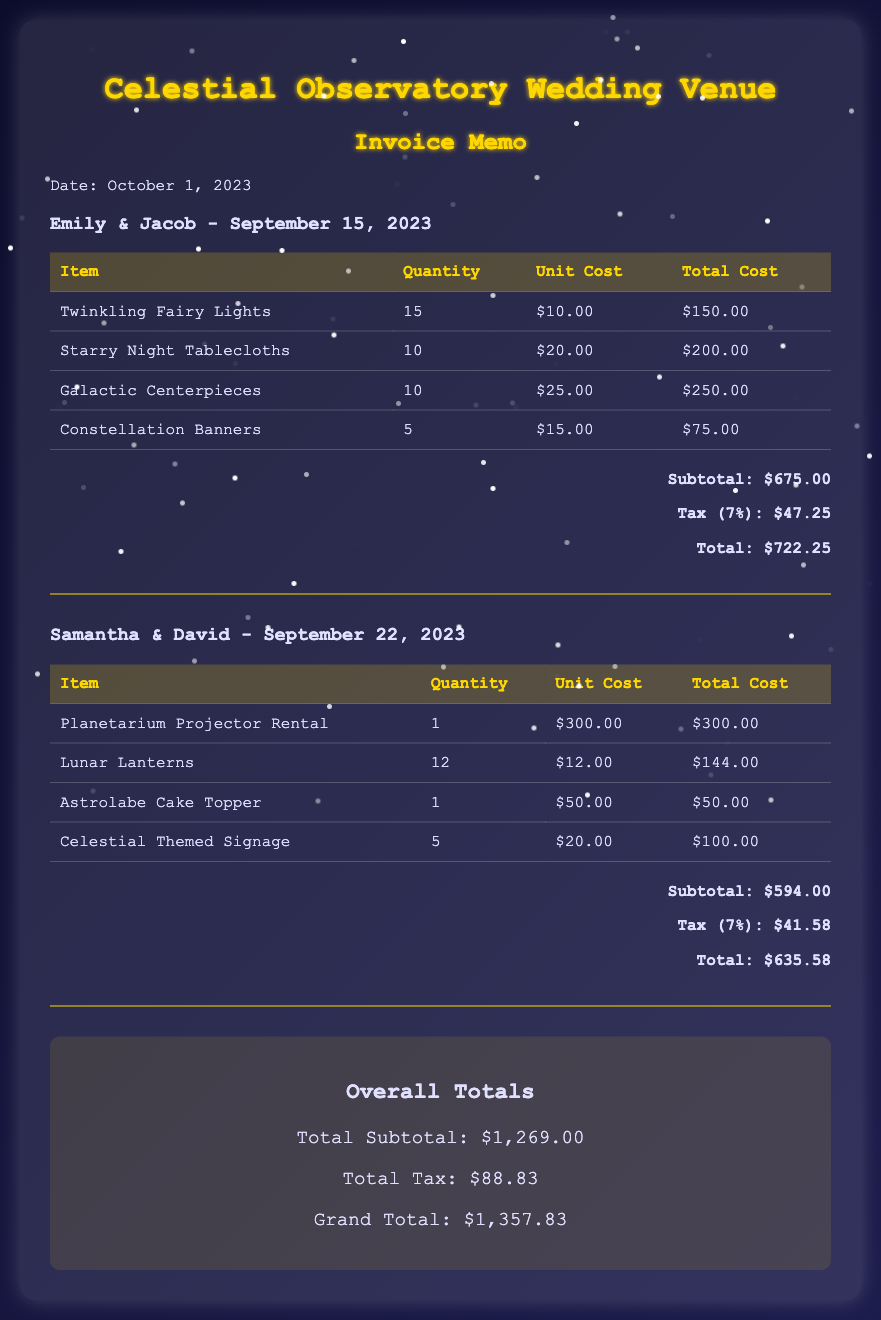What is the name of the first couple? The first couple mentioned in the document is Emily & Jacob.
Answer: Emily & Jacob What is the total cost of decorations for Samantha & David's wedding? The total cost for Samantha & David's wedding decorations is provided directly in the document.
Answer: $635.58 How many Galactic Centerpieces were purchased? The document lists the quantity of Galactic Centerpieces purchased.
Answer: 10 What is the tax percentage applied to the invoices? The tax percentage applied to the invoices is explicitly stated in the document.
Answer: 7% What date was the invoice memo created? The date of the memo is mentioned at the top of the document.
Answer: October 1, 2023 What is the grand total for all weddings combined? The grand total for all weddings is calculated and shown at the bottom of the document.
Answer: $1,357.83 What is the unit cost of Twinkling Fairy Lights? The document specifies the unit cost of Twinkling Fairy Lights directly.
Answer: $10.00 How many items in total were listed for the wedding events? By adding the number of items listed for both weddings, the total can be determined.
Answer: 7 What is the overall total subtotal listed in the memo? The overall total subtotal is calculated and presented in the overall totals section.
Answer: $1,269.00 